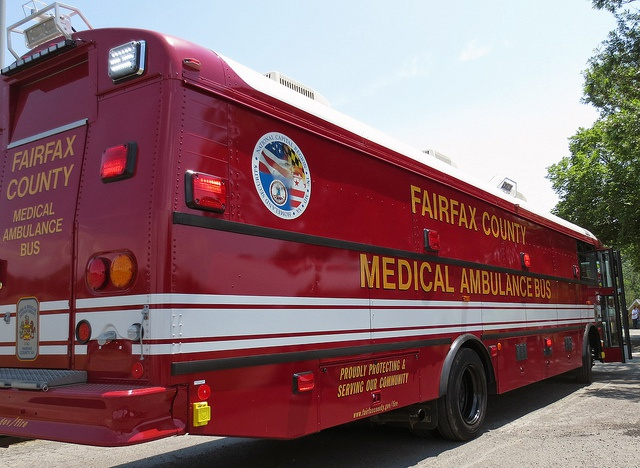Describe the objects in this image and their specific colors. I can see truck in gray, maroon, purple, black, and brown tones, bus in gray, maroon, purple, black, and brown tones, and people in gray, black, and darkgray tones in this image. 